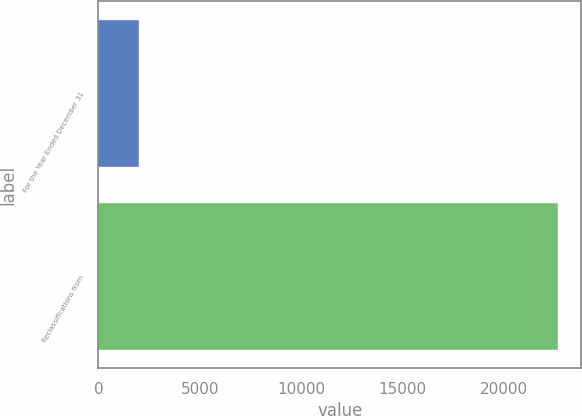<chart> <loc_0><loc_0><loc_500><loc_500><bar_chart><fcel>For the Year Ended December 31<fcel>Reclassifications from<nl><fcel>2016<fcel>22677<nl></chart> 